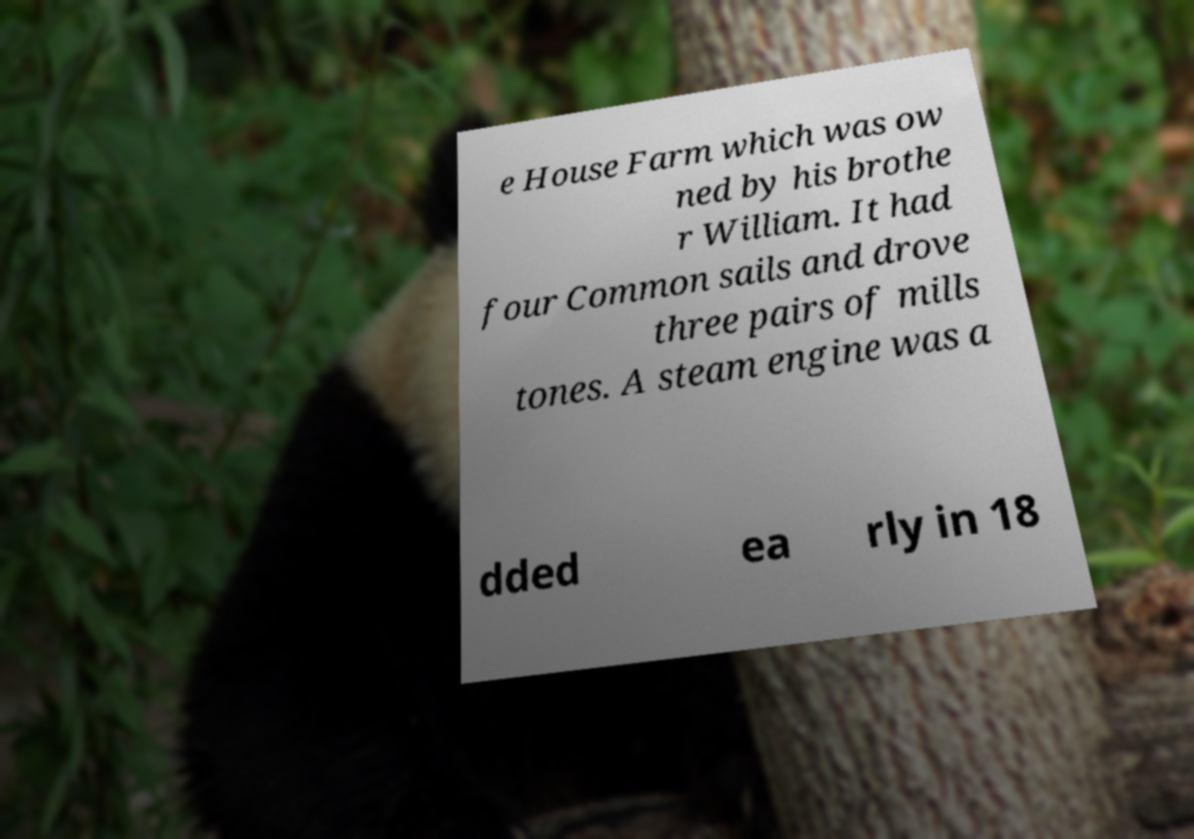Could you assist in decoding the text presented in this image and type it out clearly? e House Farm which was ow ned by his brothe r William. It had four Common sails and drove three pairs of mills tones. A steam engine was a dded ea rly in 18 